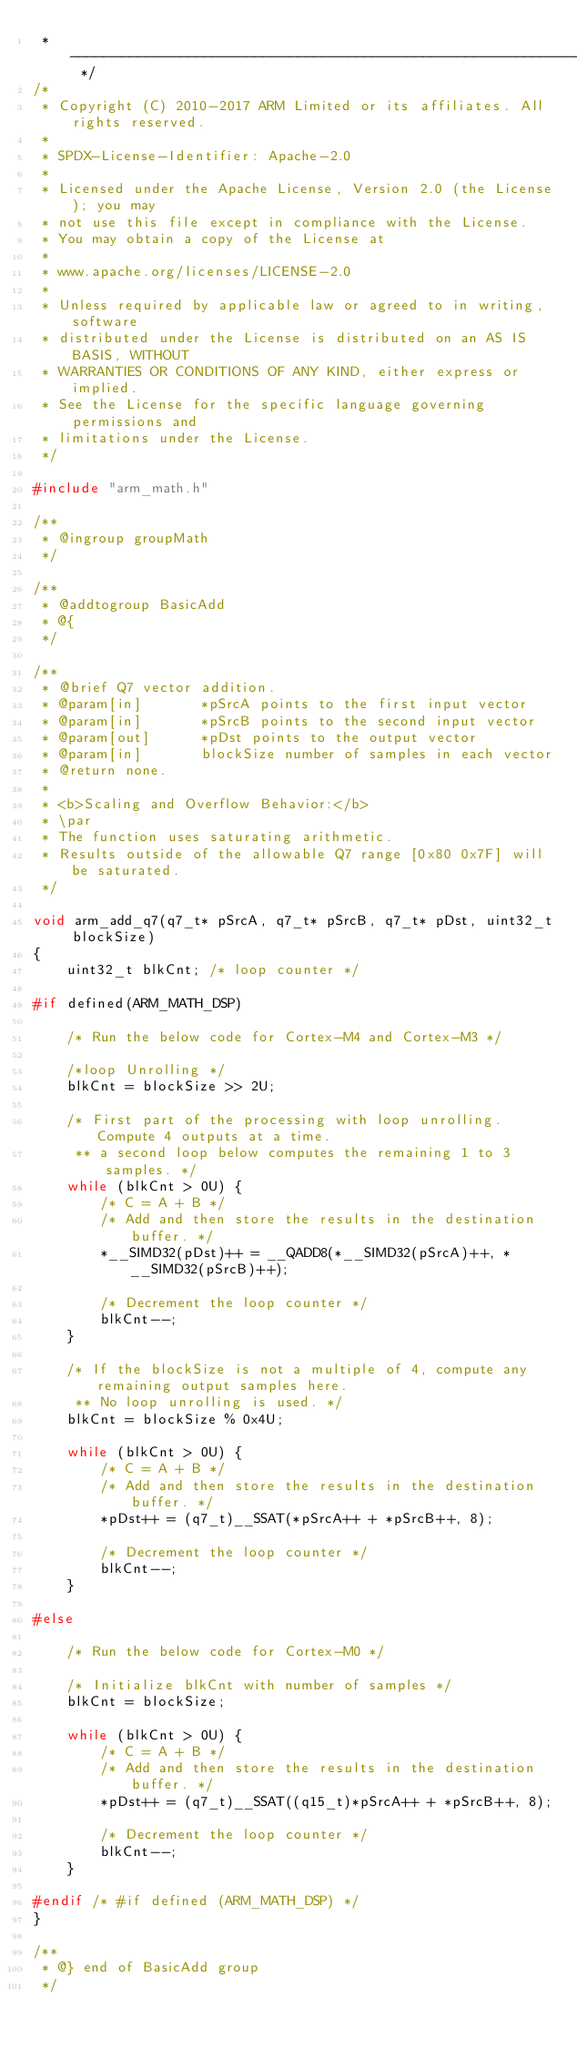Convert code to text. <code><loc_0><loc_0><loc_500><loc_500><_C_> * -------------------------------------------------------------------- */
/*
 * Copyright (C) 2010-2017 ARM Limited or its affiliates. All rights reserved.
 *
 * SPDX-License-Identifier: Apache-2.0
 *
 * Licensed under the Apache License, Version 2.0 (the License); you may
 * not use this file except in compliance with the License.
 * You may obtain a copy of the License at
 *
 * www.apache.org/licenses/LICENSE-2.0
 *
 * Unless required by applicable law or agreed to in writing, software
 * distributed under the License is distributed on an AS IS BASIS, WITHOUT
 * WARRANTIES OR CONDITIONS OF ANY KIND, either express or implied.
 * See the License for the specific language governing permissions and
 * limitations under the License.
 */

#include "arm_math.h"

/**
 * @ingroup groupMath
 */

/**
 * @addtogroup BasicAdd
 * @{
 */

/**
 * @brief Q7 vector addition.
 * @param[in]       *pSrcA points to the first input vector
 * @param[in]       *pSrcB points to the second input vector
 * @param[out]      *pDst points to the output vector
 * @param[in]       blockSize number of samples in each vector
 * @return none.
 *
 * <b>Scaling and Overflow Behavior:</b>
 * \par
 * The function uses saturating arithmetic.
 * Results outside of the allowable Q7 range [0x80 0x7F] will be saturated.
 */

void arm_add_q7(q7_t* pSrcA, q7_t* pSrcB, q7_t* pDst, uint32_t blockSize)
{
    uint32_t blkCnt; /* loop counter */

#if defined(ARM_MATH_DSP)

    /* Run the below code for Cortex-M4 and Cortex-M3 */

    /*loop Unrolling */
    blkCnt = blockSize >> 2U;

    /* First part of the processing with loop unrolling.  Compute 4 outputs at a time.
     ** a second loop below computes the remaining 1 to 3 samples. */
    while (blkCnt > 0U) {
        /* C = A + B */
        /* Add and then store the results in the destination buffer. */
        *__SIMD32(pDst)++ = __QADD8(*__SIMD32(pSrcA)++, *__SIMD32(pSrcB)++);

        /* Decrement the loop counter */
        blkCnt--;
    }

    /* If the blockSize is not a multiple of 4, compute any remaining output samples here.
     ** No loop unrolling is used. */
    blkCnt = blockSize % 0x4U;

    while (blkCnt > 0U) {
        /* C = A + B */
        /* Add and then store the results in the destination buffer. */
        *pDst++ = (q7_t)__SSAT(*pSrcA++ + *pSrcB++, 8);

        /* Decrement the loop counter */
        blkCnt--;
    }

#else

    /* Run the below code for Cortex-M0 */

    /* Initialize blkCnt with number of samples */
    blkCnt = blockSize;

    while (blkCnt > 0U) {
        /* C = A + B */
        /* Add and then store the results in the destination buffer. */
        *pDst++ = (q7_t)__SSAT((q15_t)*pSrcA++ + *pSrcB++, 8);

        /* Decrement the loop counter */
        blkCnt--;
    }

#endif /* #if defined (ARM_MATH_DSP) */
}

/**
 * @} end of BasicAdd group
 */
</code> 